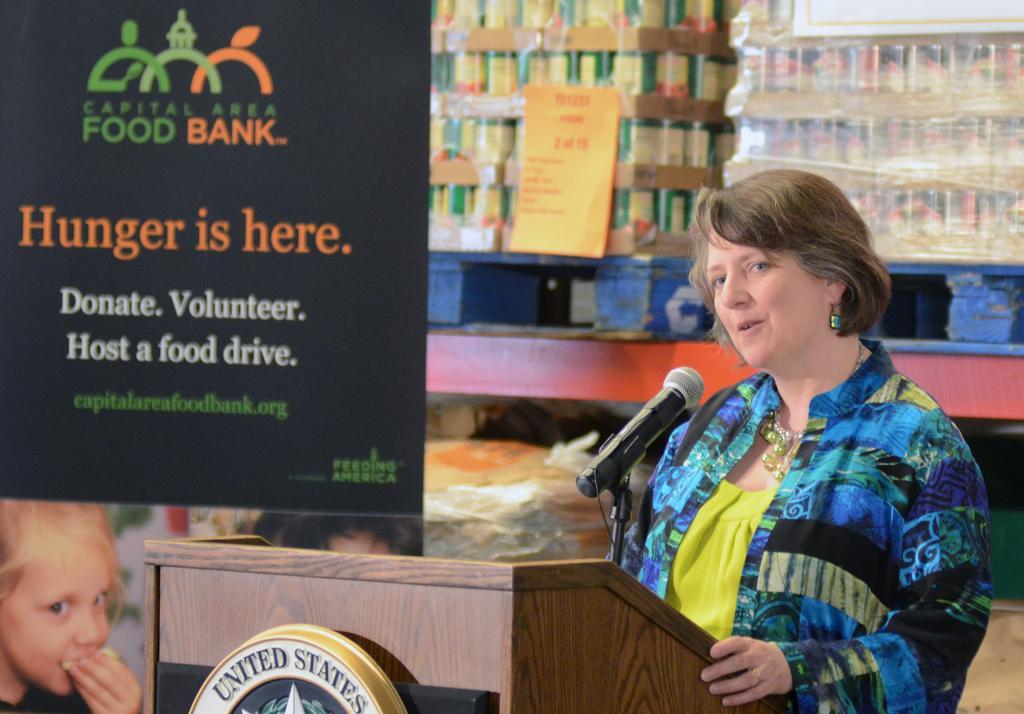How would you summarize this image in a sentence or two? In this image we can see a lady talking, in front of her there is a podium, and a mic, there is a board, with some text on it, there is a poster with some text and image on it, behind the lady we can see some packages, and boxes on the table. 